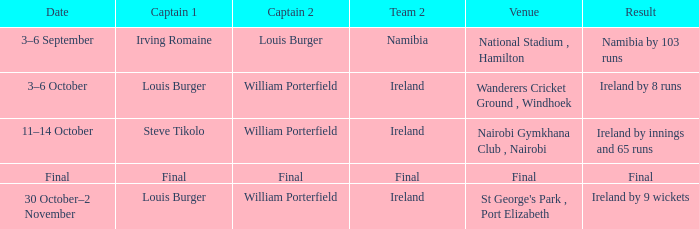Which Result has a Captain 2 of louis burger? Namibia by 103 runs. 